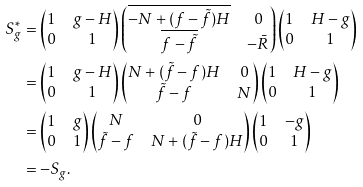Convert formula to latex. <formula><loc_0><loc_0><loc_500><loc_500>S _ { g } ^ { * } & = \begin{pmatrix} 1 & g - H \\ 0 & 1 \end{pmatrix} \begin{pmatrix} \overline { - N + ( f - \tilde { f } ) H } & 0 \\ \overline { f - \tilde { f } } & - \bar { R } \end{pmatrix} \begin{pmatrix} 1 & H - g \\ 0 & 1 \end{pmatrix} \\ & = \begin{pmatrix} 1 & g - H \\ 0 & 1 \end{pmatrix} \begin{pmatrix} N + ( \tilde { f } - f ) H & 0 \\ \tilde { f } - f & N \end{pmatrix} \begin{pmatrix} 1 & H - g \\ 0 & 1 \end{pmatrix} \\ & = \begin{pmatrix} 1 & g \\ 0 & 1 \end{pmatrix} \begin{pmatrix} N & 0 \\ \tilde { f } - f & N + ( \tilde { f } - f ) H \end{pmatrix} \begin{pmatrix} 1 & - g \\ 0 & 1 \end{pmatrix} \\ & = - S _ { g } .</formula> 